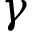<formula> <loc_0><loc_0><loc_500><loc_500>\gamma</formula> 